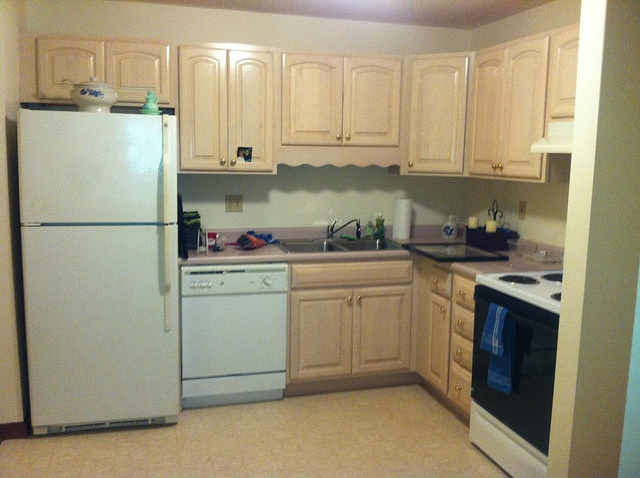Describe the objects in this image and their specific colors. I can see refrigerator in tan, darkgray, lightgray, and gray tones, oven in tan, black, darkgray, and navy tones, sink in tan, gray, black, and darkgray tones, bottle in tan, gray, and black tones, and bottle in tan, black, gray, and olive tones in this image. 